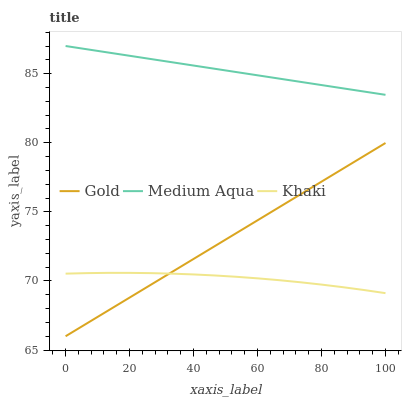Does Khaki have the minimum area under the curve?
Answer yes or no. Yes. Does Medium Aqua have the maximum area under the curve?
Answer yes or no. Yes. Does Gold have the minimum area under the curve?
Answer yes or no. No. Does Gold have the maximum area under the curve?
Answer yes or no. No. Is Gold the smoothest?
Answer yes or no. Yes. Is Khaki the roughest?
Answer yes or no. Yes. Is Medium Aqua the smoothest?
Answer yes or no. No. Is Medium Aqua the roughest?
Answer yes or no. No. Does Gold have the lowest value?
Answer yes or no. Yes. Does Medium Aqua have the lowest value?
Answer yes or no. No. Does Medium Aqua have the highest value?
Answer yes or no. Yes. Does Gold have the highest value?
Answer yes or no. No. Is Khaki less than Medium Aqua?
Answer yes or no. Yes. Is Medium Aqua greater than Gold?
Answer yes or no. Yes. Does Gold intersect Khaki?
Answer yes or no. Yes. Is Gold less than Khaki?
Answer yes or no. No. Is Gold greater than Khaki?
Answer yes or no. No. Does Khaki intersect Medium Aqua?
Answer yes or no. No. 